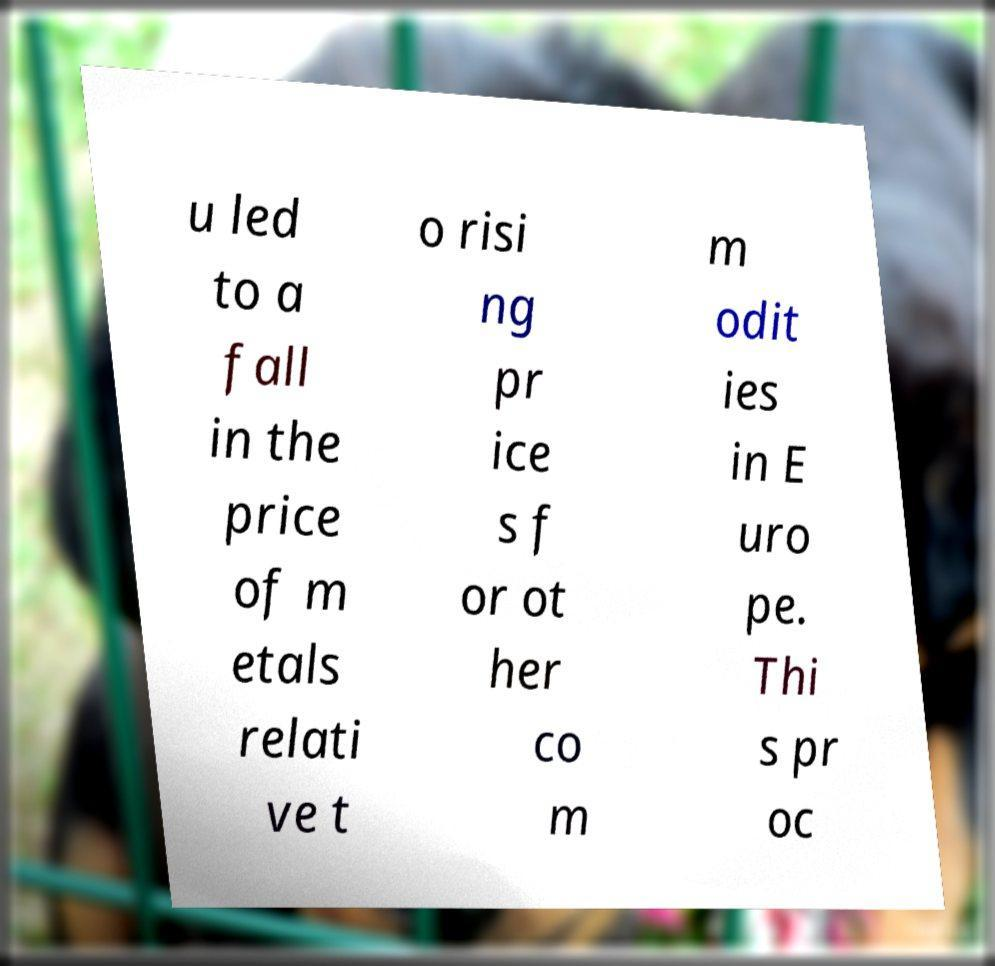There's text embedded in this image that I need extracted. Can you transcribe it verbatim? u led to a fall in the price of m etals relati ve t o risi ng pr ice s f or ot her co m m odit ies in E uro pe. Thi s pr oc 